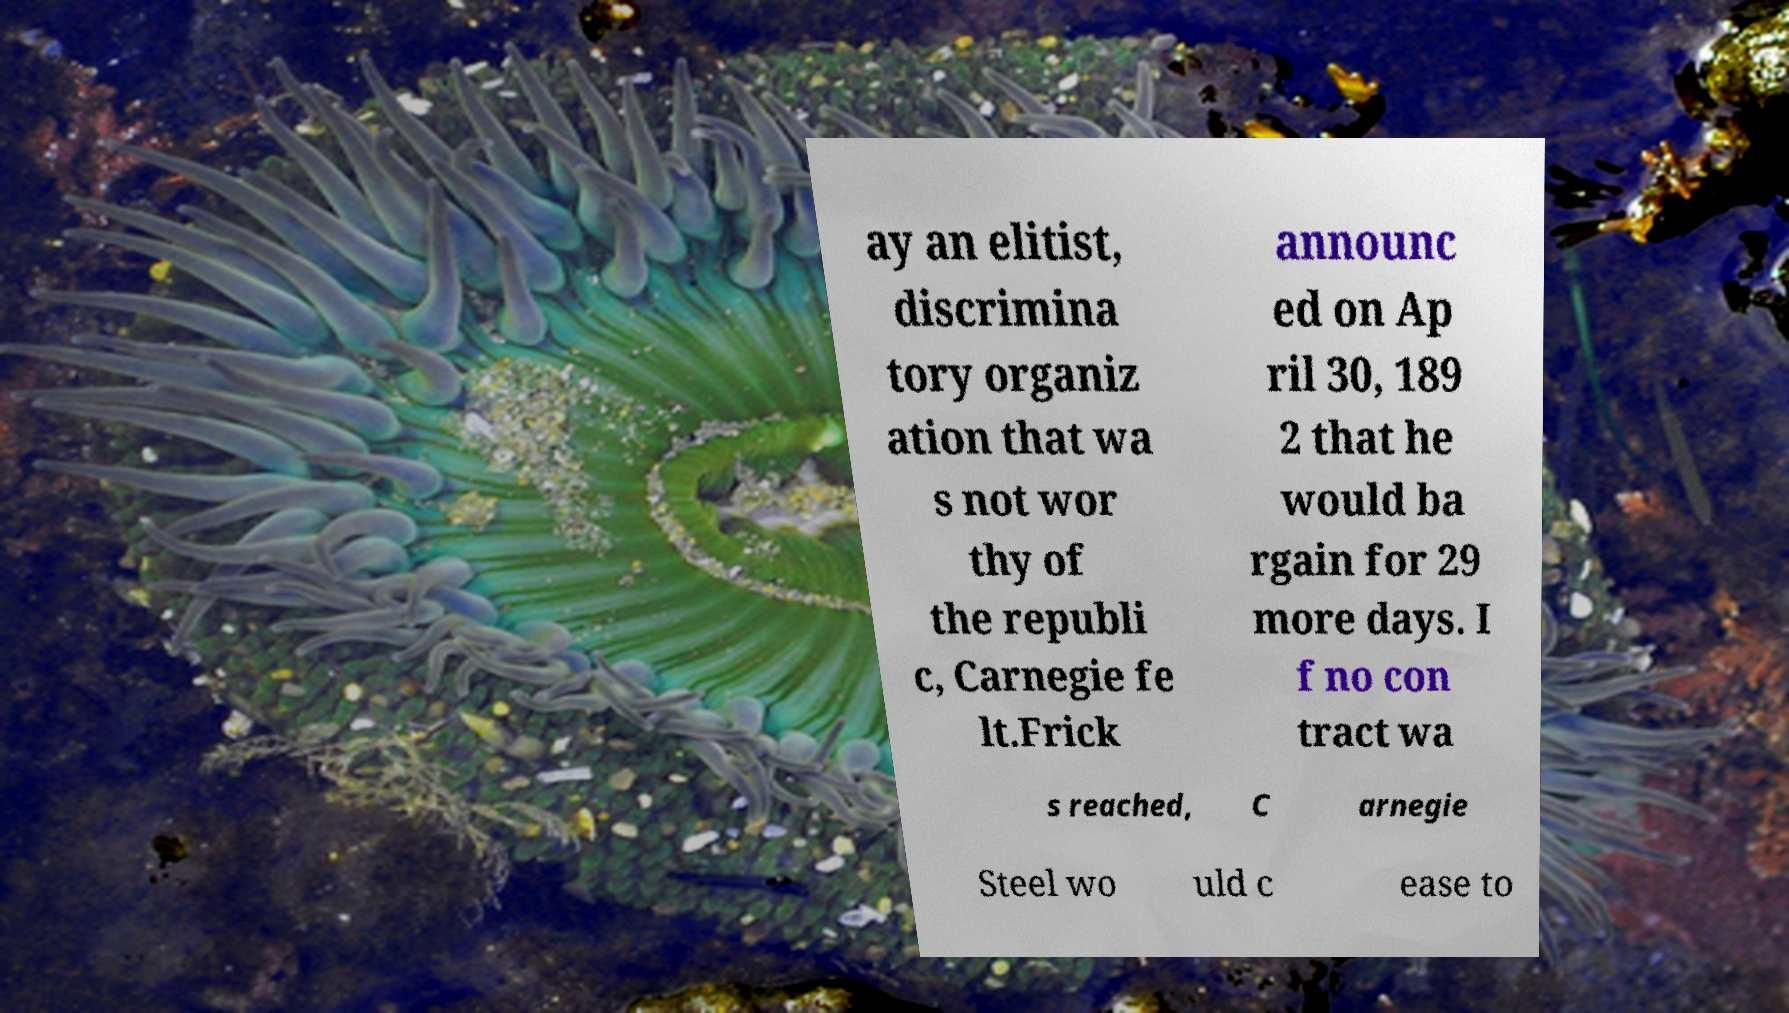Please read and relay the text visible in this image. What does it say? ay an elitist, discrimina tory organiz ation that wa s not wor thy of the republi c, Carnegie fe lt.Frick announc ed on Ap ril 30, 189 2 that he would ba rgain for 29 more days. I f no con tract wa s reached, C arnegie Steel wo uld c ease to 